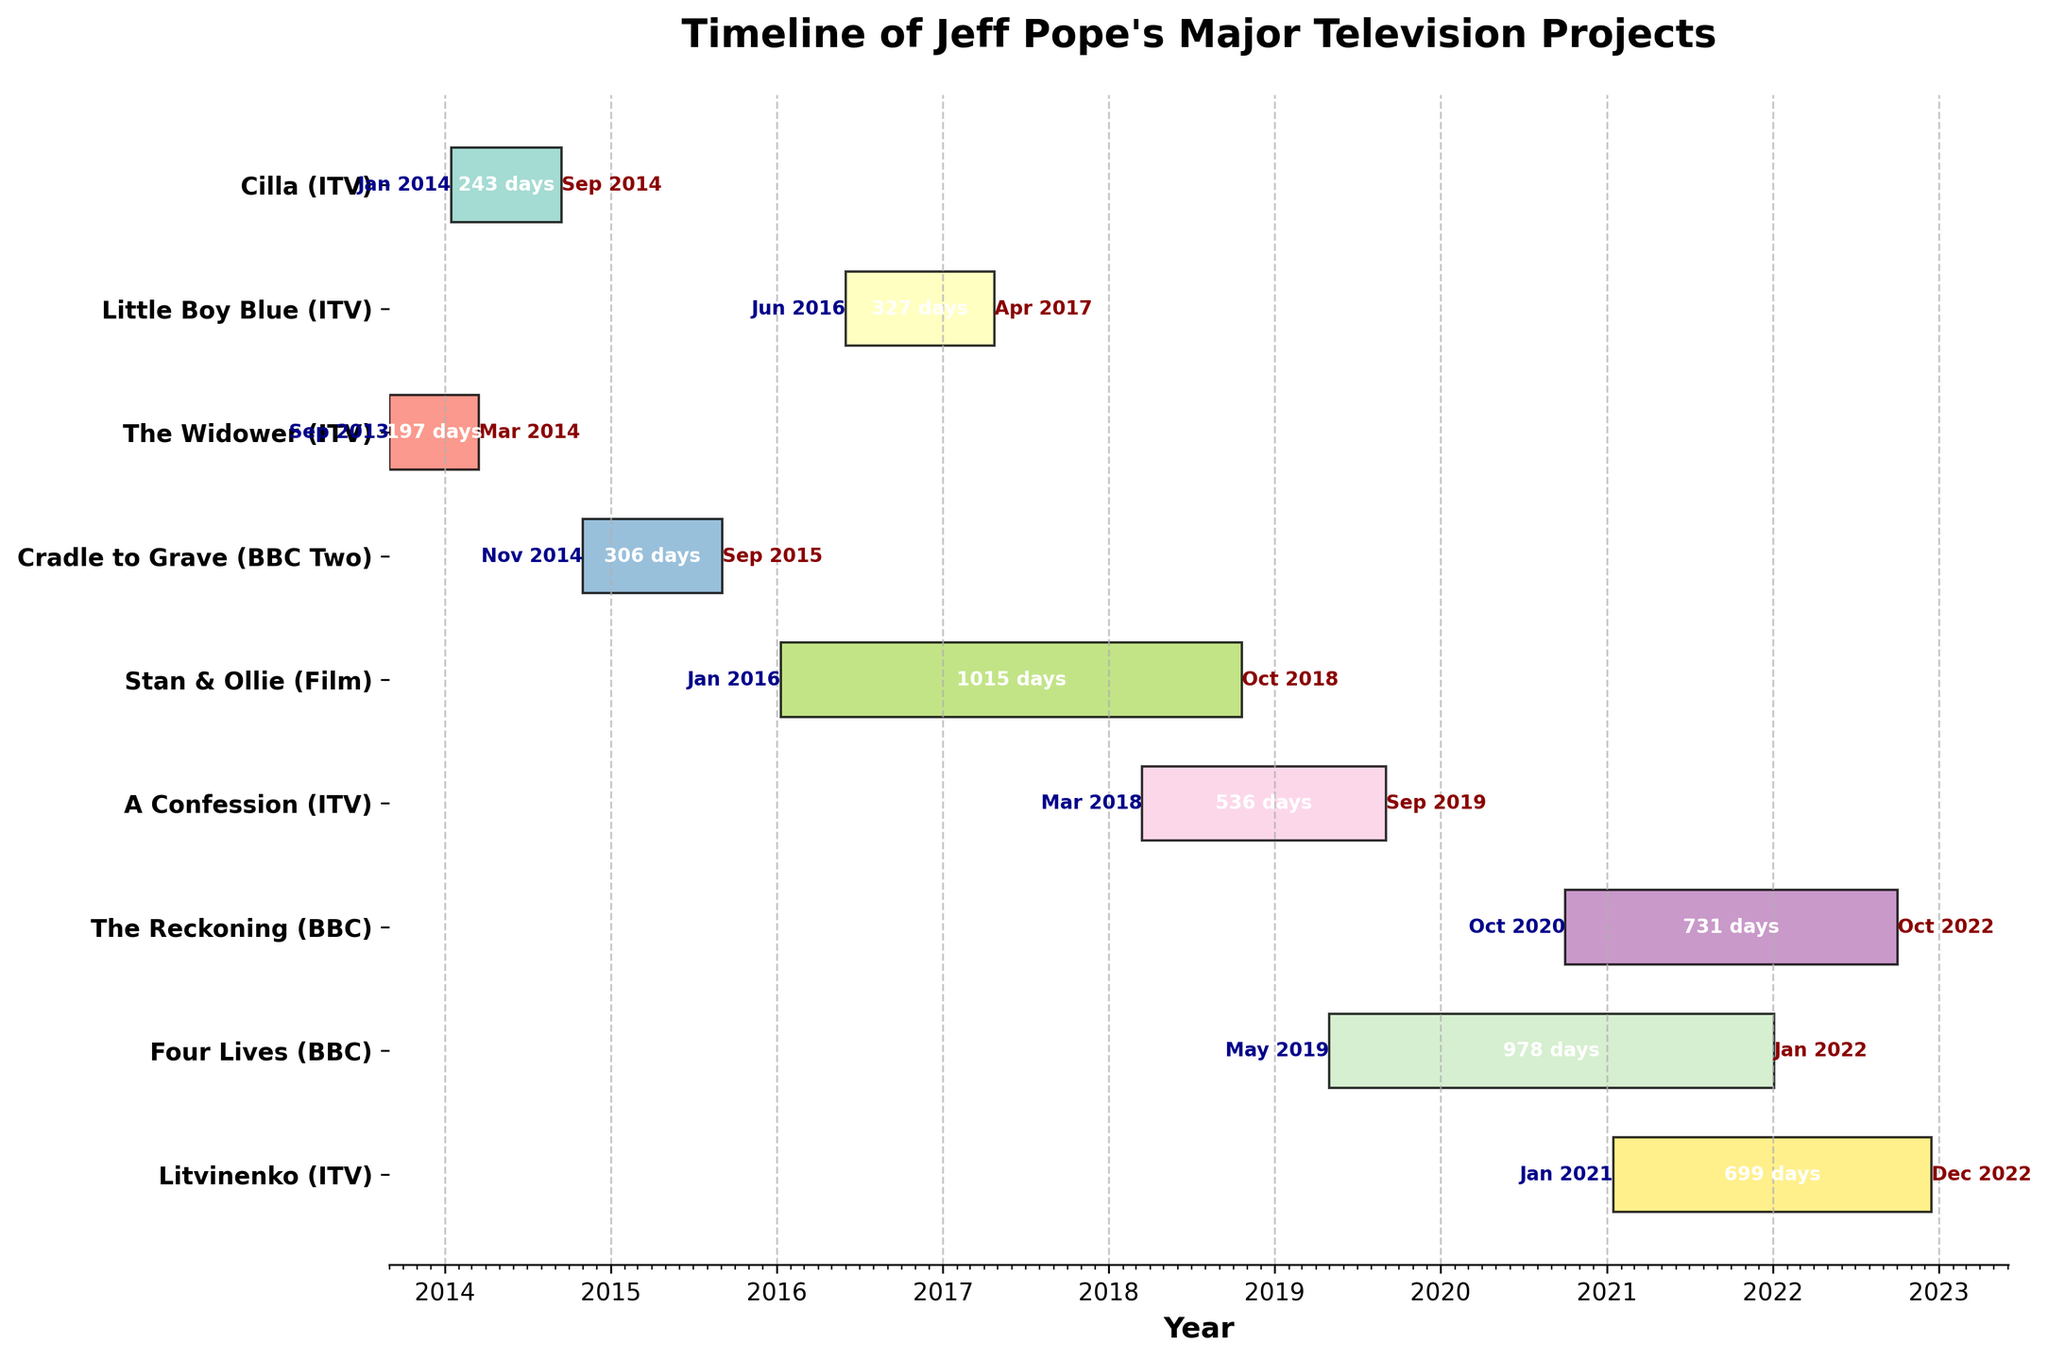what is the title of the chart? The title of the chart is displayed at the top and reads "Timeline of Jeff Pope's Major Television Projects".
Answer: Timeline of Jeff Pope's Major Television Projects How many projects are displayed on the chart? There are a total of nine projects listed on the y-axis, each associated with a specific timeline.
Answer: Nine Which project lasted the longest in terms of days? By comparing the lengths of the bars, "The Reckoning" project took the longest time, spanning from October 2020 to October 2022.
Answer: The Reckoning Between which years did the project "Stan & Ollie" start and end? The 'Stan & Ollie' project started in January 2016 and ended in October 2018, which can be seen from the bar's starting and ending points.
Answer: 2016-2018 what is the shortest project displayed? The shortest project in terms of duration is "The Widower," which lasted from September 2013 to March 2014.
Answer: The Widower Which projects were broadcast on ITV? By examining the labels on the left, you can identify "Cilla," "Little Boy Blue," "The Widower," "A Confession," and "Litvinenko" as the projects by ITV.
Answer: Cilla, Little Boy Blue, The Widower, A Confession, Litvinenko During which months did "Four Lives" start and end? The 'Four Lives' project started in May 2019 and ended in January 2022, which can be identified by examining the starting and ending positions on the timeline.
Answer: May 2019 - January 2022 Which project overlapped the most with "Little Boy Blue"? By visually inspecting the timeline, "Stan & Ollie" overlapped with "Little Boy Blue" from June 2016 to April 2017.
Answer: Stan & Ollie how long did "Cradle to Grave" last? "Cradle to Grave" lasted from November 2014 to September 2015. The duration can be calculated as 306 days.
Answer: 306 days How many projects had their end dates in 2022? By checking the end dates on the right, "The Reckoning," "Four Lives," and "Litvinenko" all concluded in 2022.
Answer: Three 